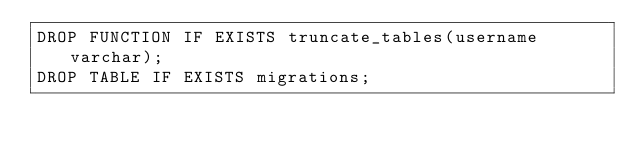Convert code to text. <code><loc_0><loc_0><loc_500><loc_500><_SQL_>DROP FUNCTION IF EXISTS truncate_tables(username varchar);
DROP TABLE IF EXISTS migrations;
</code> 